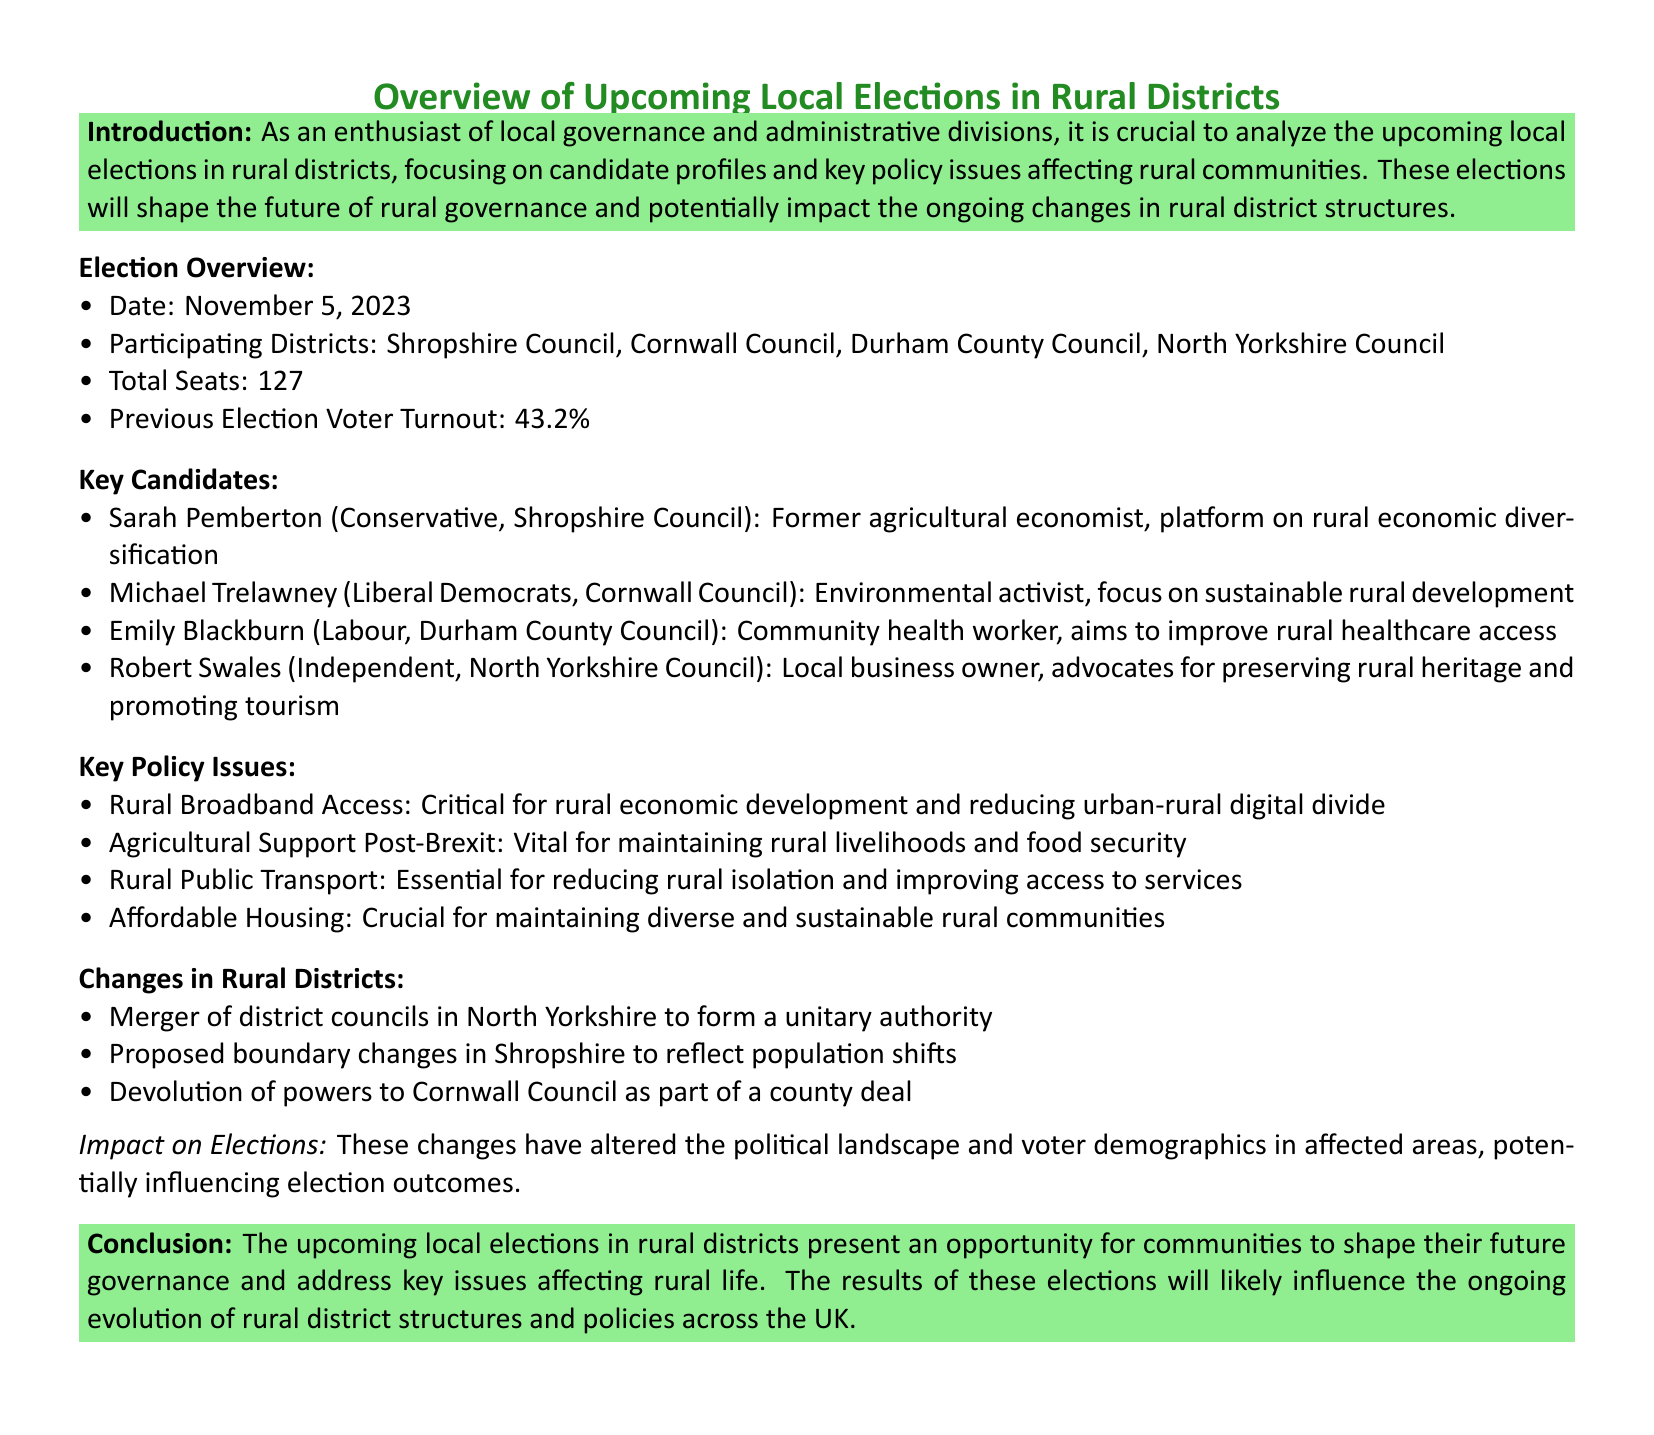What is the date of the upcoming local elections? The date for the upcoming local elections is specifically mentioned in the document.
Answer: November 5, 2023 How many total seats are available in these elections? The document indicates the number of total seats up for election in rural districts.
Answer: 127 Who is the candidate for the Conservative party in Shropshire Council? The memo lists the key candidates along with their party affiliations and districts.
Answer: Sarah Pemberton What key platform does Michael Trelawney focus on? The document outlines the key platforms of each candidate, mentioning their main focus.
Answer: Sustainable rural development What is a critical issue affecting rural communities mentioned in the document? The document presents several key policy issues relevant to rural areas, highlighting their significance.
Answer: Rural Broadband Access Which council experienced a merger to form a unitary authority? The recent developments section describes changes within rural districts, including mergers.
Answer: North Yorkshire What was the voter turnout percentage in the previous election? The memo provides statistics regarding voter turnout from the previous election.
Answer: 43.2% What background does Emily Blackburn have? The candidates' profiles include their backgrounds and experiences which inform their candidacy.
Answer: Community health worker What impact do recent changes have on the elections? The document specifies how changes in rural districts may affect political landscapes and voter demographics.
Answer: Influencing election outcomes 